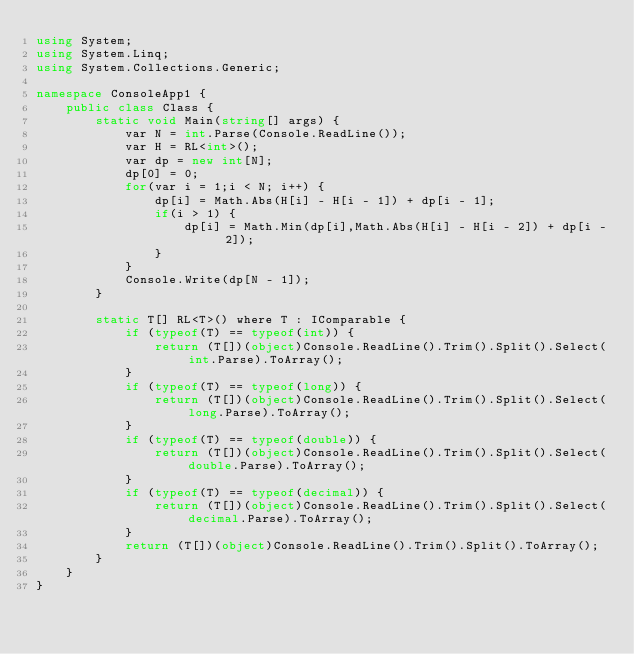Convert code to text. <code><loc_0><loc_0><loc_500><loc_500><_C#_>using System;
using System.Linq;
using System.Collections.Generic;

namespace ConsoleApp1 {
    public class Class {
        static void Main(string[] args) {
            var N = int.Parse(Console.ReadLine());
            var H = RL<int>();
            var dp = new int[N];
            dp[0] = 0;
            for(var i = 1;i < N; i++) {
                dp[i] = Math.Abs(H[i] - H[i - 1]) + dp[i - 1];
                if(i > 1) {
                    dp[i] = Math.Min(dp[i],Math.Abs(H[i] - H[i - 2]) + dp[i - 2]);
                }
            }
            Console.Write(dp[N - 1]);
        }

        static T[] RL<T>() where T : IComparable {
            if (typeof(T) == typeof(int)) {
                return (T[])(object)Console.ReadLine().Trim().Split().Select(int.Parse).ToArray();
            }
            if (typeof(T) == typeof(long)) {
                return (T[])(object)Console.ReadLine().Trim().Split().Select(long.Parse).ToArray();
            }
            if (typeof(T) == typeof(double)) {
                return (T[])(object)Console.ReadLine().Trim().Split().Select(double.Parse).ToArray();
            }
            if (typeof(T) == typeof(decimal)) {
                return (T[])(object)Console.ReadLine().Trim().Split().Select(decimal.Parse).ToArray();
            }
            return (T[])(object)Console.ReadLine().Trim().Split().ToArray();
        }
    }
}</code> 